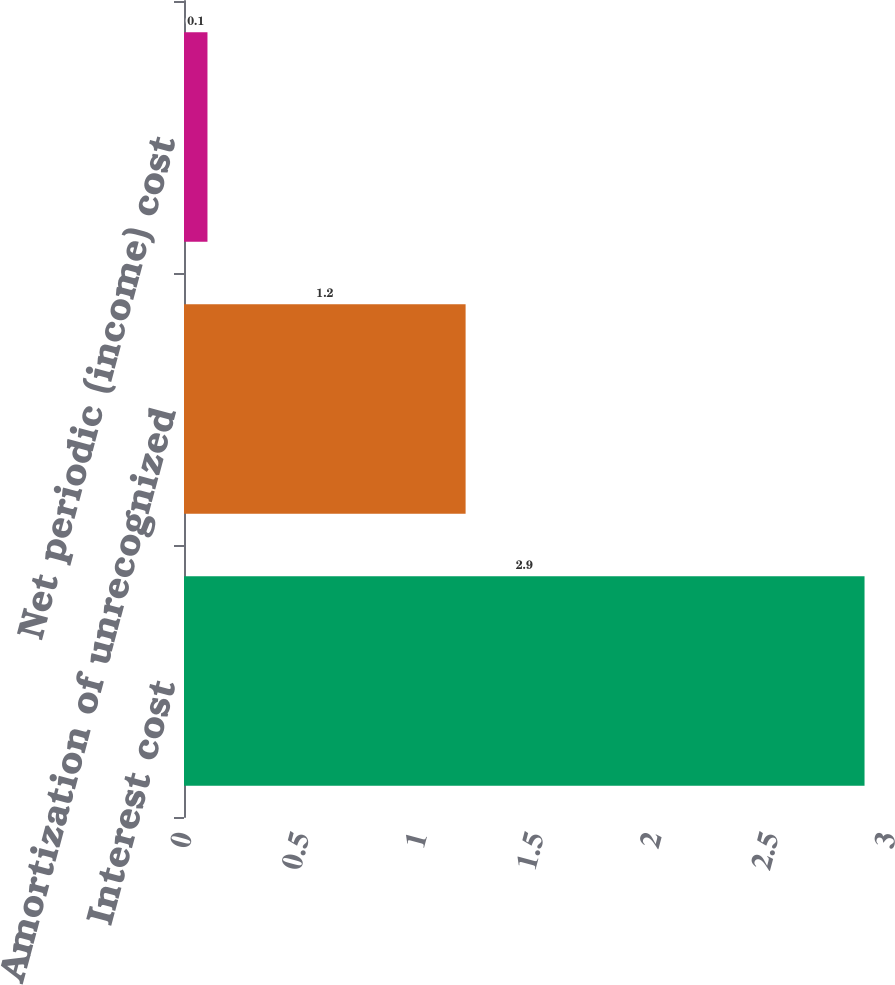Convert chart to OTSL. <chart><loc_0><loc_0><loc_500><loc_500><bar_chart><fcel>Interest cost<fcel>Amortization of unrecognized<fcel>Net periodic (income) cost<nl><fcel>2.9<fcel>1.2<fcel>0.1<nl></chart> 